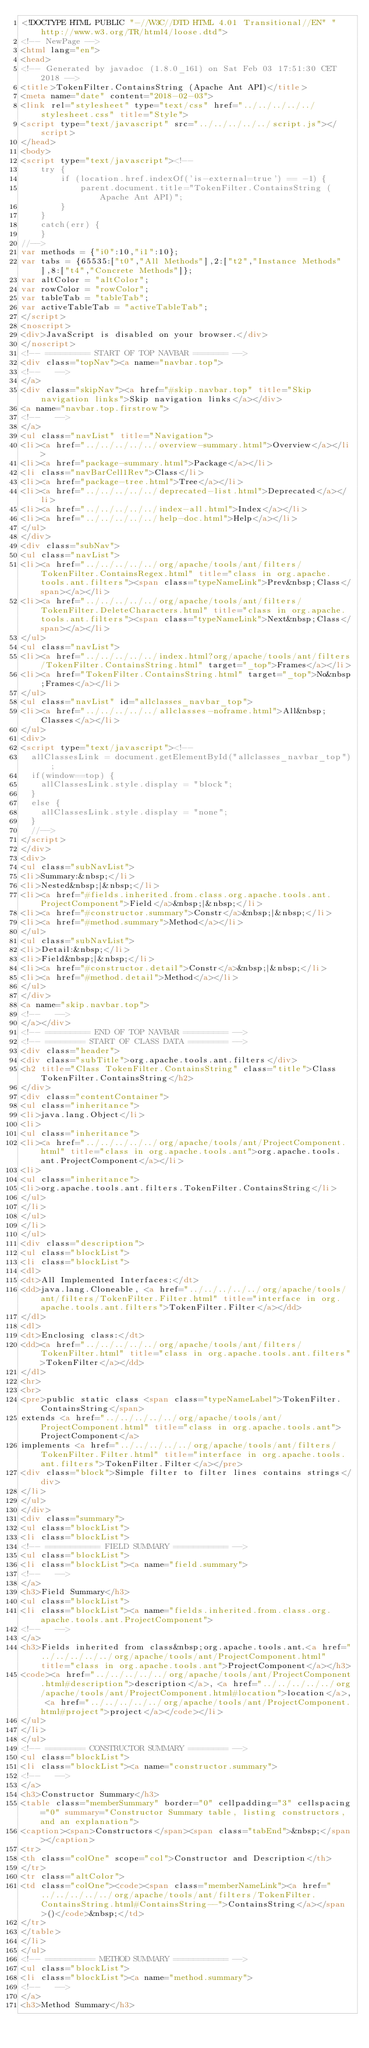<code> <loc_0><loc_0><loc_500><loc_500><_HTML_><!DOCTYPE HTML PUBLIC "-//W3C//DTD HTML 4.01 Transitional//EN" "http://www.w3.org/TR/html4/loose.dtd">
<!-- NewPage -->
<html lang="en">
<head>
<!-- Generated by javadoc (1.8.0_161) on Sat Feb 03 17:51:30 CET 2018 -->
<title>TokenFilter.ContainsString (Apache Ant API)</title>
<meta name="date" content="2018-02-03">
<link rel="stylesheet" type="text/css" href="../../../../../stylesheet.css" title="Style">
<script type="text/javascript" src="../../../../../script.js"></script>
</head>
<body>
<script type="text/javascript"><!--
    try {
        if (location.href.indexOf('is-external=true') == -1) {
            parent.document.title="TokenFilter.ContainsString (Apache Ant API)";
        }
    }
    catch(err) {
    }
//-->
var methods = {"i0":10,"i1":10};
var tabs = {65535:["t0","All Methods"],2:["t2","Instance Methods"],8:["t4","Concrete Methods"]};
var altColor = "altColor";
var rowColor = "rowColor";
var tableTab = "tableTab";
var activeTableTab = "activeTableTab";
</script>
<noscript>
<div>JavaScript is disabled on your browser.</div>
</noscript>
<!-- ========= START OF TOP NAVBAR ======= -->
<div class="topNav"><a name="navbar.top">
<!--   -->
</a>
<div class="skipNav"><a href="#skip.navbar.top" title="Skip navigation links">Skip navigation links</a></div>
<a name="navbar.top.firstrow">
<!--   -->
</a>
<ul class="navList" title="Navigation">
<li><a href="../../../../../overview-summary.html">Overview</a></li>
<li><a href="package-summary.html">Package</a></li>
<li class="navBarCell1Rev">Class</li>
<li><a href="package-tree.html">Tree</a></li>
<li><a href="../../../../../deprecated-list.html">Deprecated</a></li>
<li><a href="../../../../../index-all.html">Index</a></li>
<li><a href="../../../../../help-doc.html">Help</a></li>
</ul>
</div>
<div class="subNav">
<ul class="navList">
<li><a href="../../../../../org/apache/tools/ant/filters/TokenFilter.ContainsRegex.html" title="class in org.apache.tools.ant.filters"><span class="typeNameLink">Prev&nbsp;Class</span></a></li>
<li><a href="../../../../../org/apache/tools/ant/filters/TokenFilter.DeleteCharacters.html" title="class in org.apache.tools.ant.filters"><span class="typeNameLink">Next&nbsp;Class</span></a></li>
</ul>
<ul class="navList">
<li><a href="../../../../../index.html?org/apache/tools/ant/filters/TokenFilter.ContainsString.html" target="_top">Frames</a></li>
<li><a href="TokenFilter.ContainsString.html" target="_top">No&nbsp;Frames</a></li>
</ul>
<ul class="navList" id="allclasses_navbar_top">
<li><a href="../../../../../allclasses-noframe.html">All&nbsp;Classes</a></li>
</ul>
<div>
<script type="text/javascript"><!--
  allClassesLink = document.getElementById("allclasses_navbar_top");
  if(window==top) {
    allClassesLink.style.display = "block";
  }
  else {
    allClassesLink.style.display = "none";
  }
  //-->
</script>
</div>
<div>
<ul class="subNavList">
<li>Summary:&nbsp;</li>
<li>Nested&nbsp;|&nbsp;</li>
<li><a href="#fields.inherited.from.class.org.apache.tools.ant.ProjectComponent">Field</a>&nbsp;|&nbsp;</li>
<li><a href="#constructor.summary">Constr</a>&nbsp;|&nbsp;</li>
<li><a href="#method.summary">Method</a></li>
</ul>
<ul class="subNavList">
<li>Detail:&nbsp;</li>
<li>Field&nbsp;|&nbsp;</li>
<li><a href="#constructor.detail">Constr</a>&nbsp;|&nbsp;</li>
<li><a href="#method.detail">Method</a></li>
</ul>
</div>
<a name="skip.navbar.top">
<!--   -->
</a></div>
<!-- ========= END OF TOP NAVBAR ========= -->
<!-- ======== START OF CLASS DATA ======== -->
<div class="header">
<div class="subTitle">org.apache.tools.ant.filters</div>
<h2 title="Class TokenFilter.ContainsString" class="title">Class TokenFilter.ContainsString</h2>
</div>
<div class="contentContainer">
<ul class="inheritance">
<li>java.lang.Object</li>
<li>
<ul class="inheritance">
<li><a href="../../../../../org/apache/tools/ant/ProjectComponent.html" title="class in org.apache.tools.ant">org.apache.tools.ant.ProjectComponent</a></li>
<li>
<ul class="inheritance">
<li>org.apache.tools.ant.filters.TokenFilter.ContainsString</li>
</ul>
</li>
</ul>
</li>
</ul>
<div class="description">
<ul class="blockList">
<li class="blockList">
<dl>
<dt>All Implemented Interfaces:</dt>
<dd>java.lang.Cloneable, <a href="../../../../../org/apache/tools/ant/filters/TokenFilter.Filter.html" title="interface in org.apache.tools.ant.filters">TokenFilter.Filter</a></dd>
</dl>
<dl>
<dt>Enclosing class:</dt>
<dd><a href="../../../../../org/apache/tools/ant/filters/TokenFilter.html" title="class in org.apache.tools.ant.filters">TokenFilter</a></dd>
</dl>
<hr>
<br>
<pre>public static class <span class="typeNameLabel">TokenFilter.ContainsString</span>
extends <a href="../../../../../org/apache/tools/ant/ProjectComponent.html" title="class in org.apache.tools.ant">ProjectComponent</a>
implements <a href="../../../../../org/apache/tools/ant/filters/TokenFilter.Filter.html" title="interface in org.apache.tools.ant.filters">TokenFilter.Filter</a></pre>
<div class="block">Simple filter to filter lines contains strings</div>
</li>
</ul>
</div>
<div class="summary">
<ul class="blockList">
<li class="blockList">
<!-- =========== FIELD SUMMARY =========== -->
<ul class="blockList">
<li class="blockList"><a name="field.summary">
<!--   -->
</a>
<h3>Field Summary</h3>
<ul class="blockList">
<li class="blockList"><a name="fields.inherited.from.class.org.apache.tools.ant.ProjectComponent">
<!--   -->
</a>
<h3>Fields inherited from class&nbsp;org.apache.tools.ant.<a href="../../../../../org/apache/tools/ant/ProjectComponent.html" title="class in org.apache.tools.ant">ProjectComponent</a></h3>
<code><a href="../../../../../org/apache/tools/ant/ProjectComponent.html#description">description</a>, <a href="../../../../../org/apache/tools/ant/ProjectComponent.html#location">location</a>, <a href="../../../../../org/apache/tools/ant/ProjectComponent.html#project">project</a></code></li>
</ul>
</li>
</ul>
<!-- ======== CONSTRUCTOR SUMMARY ======== -->
<ul class="blockList">
<li class="blockList"><a name="constructor.summary">
<!--   -->
</a>
<h3>Constructor Summary</h3>
<table class="memberSummary" border="0" cellpadding="3" cellspacing="0" summary="Constructor Summary table, listing constructors, and an explanation">
<caption><span>Constructors</span><span class="tabEnd">&nbsp;</span></caption>
<tr>
<th class="colOne" scope="col">Constructor and Description</th>
</tr>
<tr class="altColor">
<td class="colOne"><code><span class="memberNameLink"><a href="../../../../../org/apache/tools/ant/filters/TokenFilter.ContainsString.html#ContainsString--">ContainsString</a></span>()</code>&nbsp;</td>
</tr>
</table>
</li>
</ul>
<!-- ========== METHOD SUMMARY =========== -->
<ul class="blockList">
<li class="blockList"><a name="method.summary">
<!--   -->
</a>
<h3>Method Summary</h3></code> 